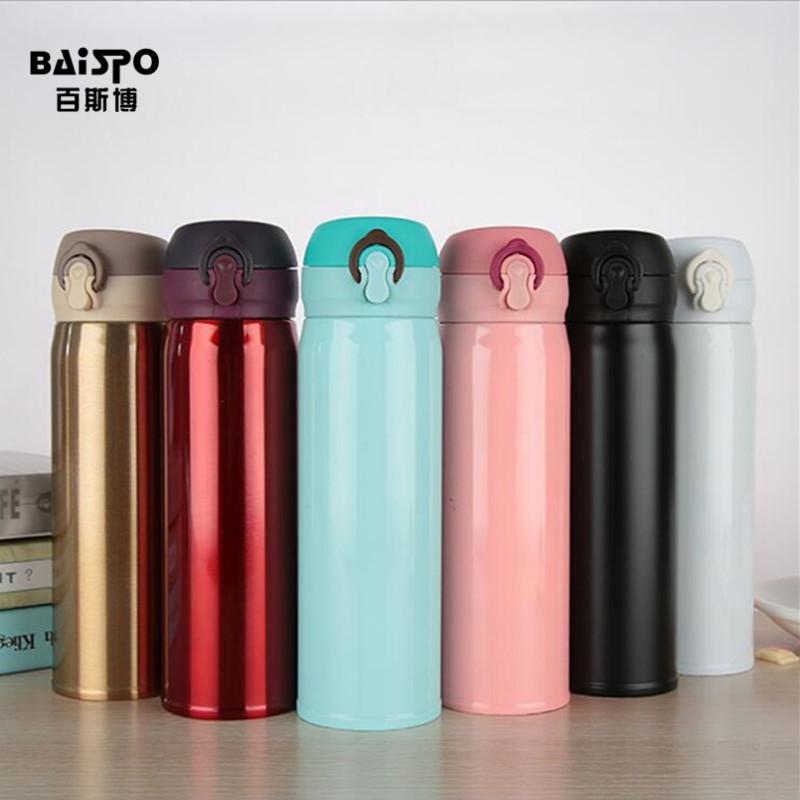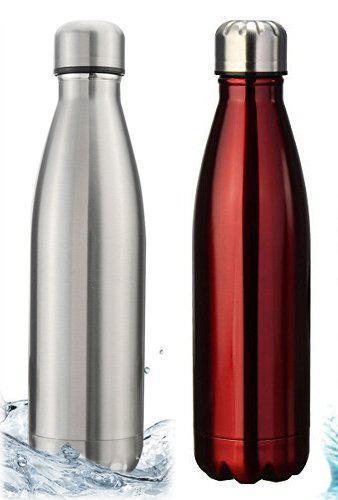The first image is the image on the left, the second image is the image on the right. Evaluate the accuracy of this statement regarding the images: "The bottles in one of the images are sitting outside.". Is it true? Answer yes or no. No. The first image is the image on the left, the second image is the image on the right. Assess this claim about the two images: "In one image, five bottles with chrome caps and dimpled bottom sections are the same design, but in different colors". Correct or not? Answer yes or no. No. 